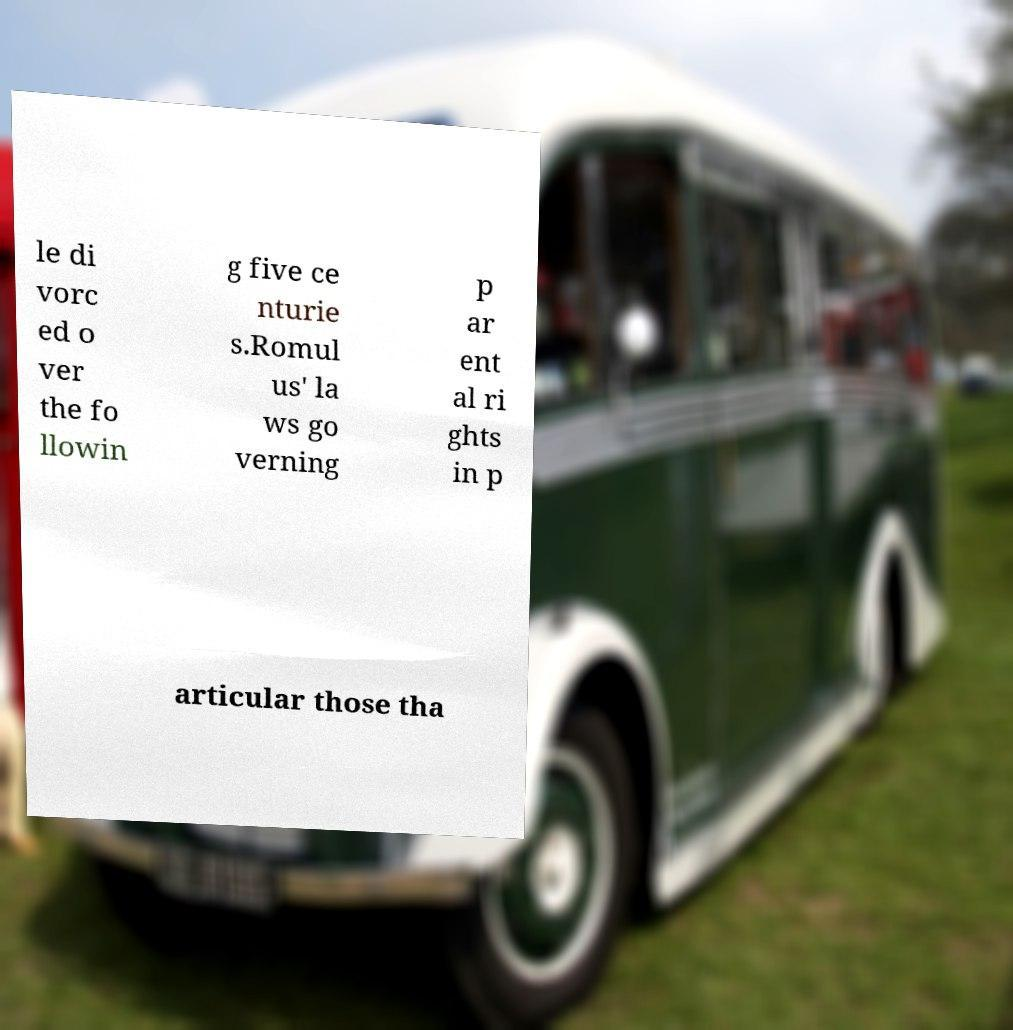Can you read and provide the text displayed in the image?This photo seems to have some interesting text. Can you extract and type it out for me? le di vorc ed o ver the fo llowin g five ce nturie s.Romul us' la ws go verning p ar ent al ri ghts in p articular those tha 